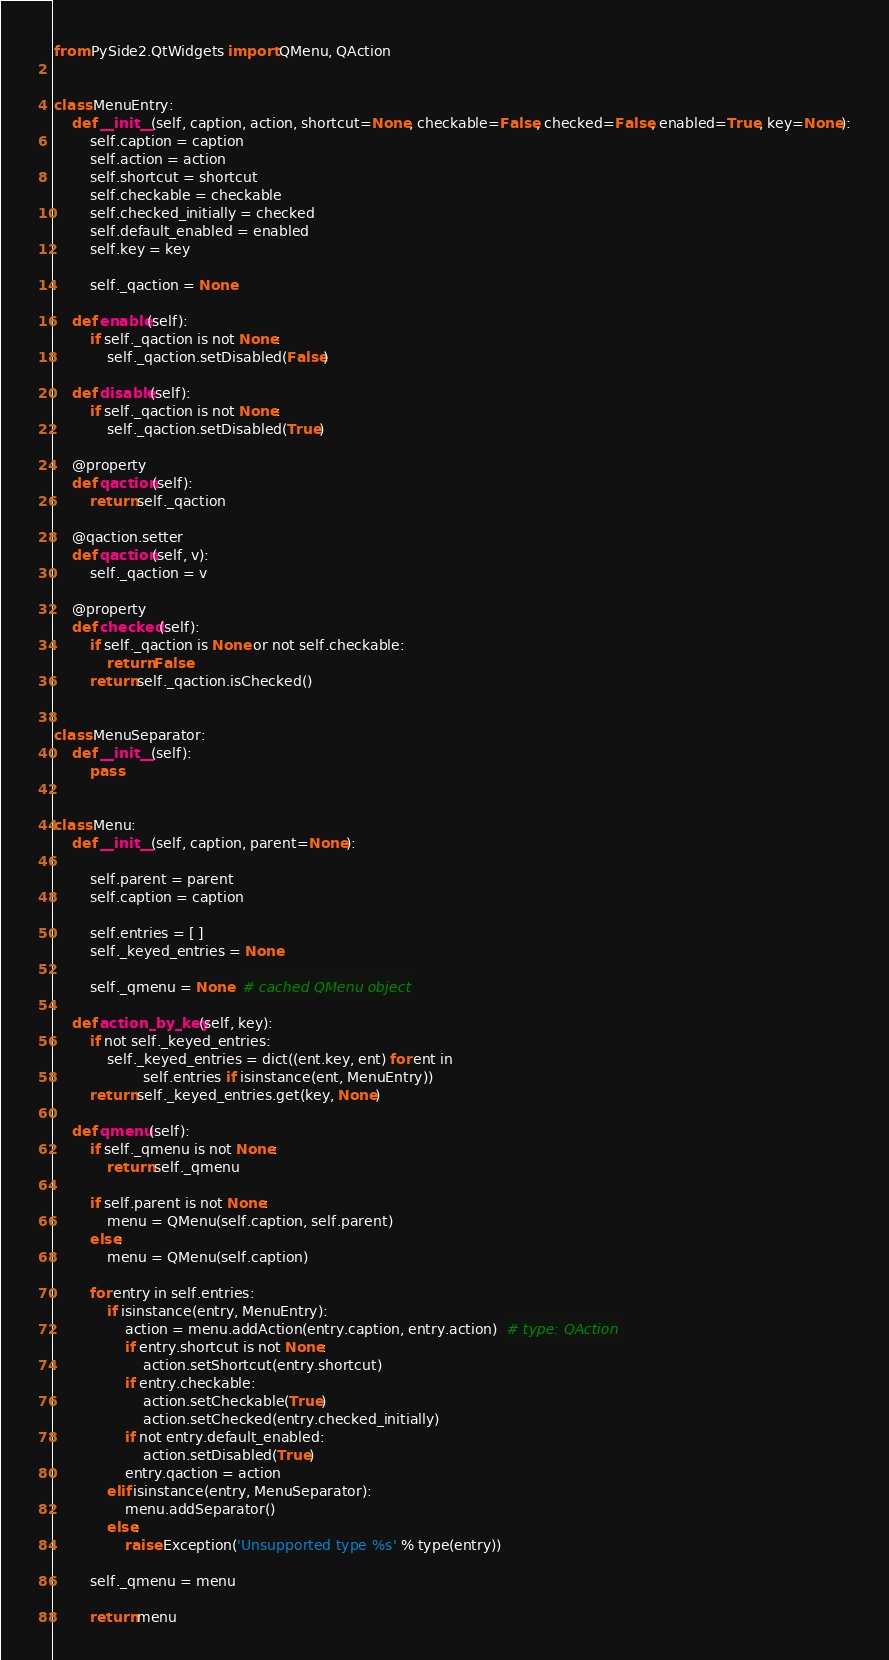<code> <loc_0><loc_0><loc_500><loc_500><_Python_>from PySide2.QtWidgets import QMenu, QAction


class MenuEntry:
    def __init__(self, caption, action, shortcut=None, checkable=False, checked=False, enabled=True, key=None):
        self.caption = caption
        self.action = action
        self.shortcut = shortcut
        self.checkable = checkable
        self.checked_initially = checked
        self.default_enabled = enabled
        self.key = key

        self._qaction = None

    def enable(self):
        if self._qaction is not None:
            self._qaction.setDisabled(False)

    def disable(self):
        if self._qaction is not None:
            self._qaction.setDisabled(True)

    @property
    def qaction(self):
        return self._qaction

    @qaction.setter
    def qaction(self, v):
        self._qaction = v

    @property
    def checked(self):
        if self._qaction is None or not self.checkable:
            return False
        return self._qaction.isChecked()


class MenuSeparator:
    def __init__(self):
        pass


class Menu:
    def __init__(self, caption, parent=None):

        self.parent = parent
        self.caption = caption

        self.entries = [ ]
        self._keyed_entries = None

        self._qmenu = None  # cached QMenu object

    def action_by_key(self, key):
        if not self._keyed_entries:
            self._keyed_entries = dict((ent.key, ent) for ent in
                    self.entries if isinstance(ent, MenuEntry))
        return self._keyed_entries.get(key, None)

    def qmenu(self):
        if self._qmenu is not None:
            return self._qmenu

        if self.parent is not None:
            menu = QMenu(self.caption, self.parent)
        else:
            menu = QMenu(self.caption)

        for entry in self.entries:
            if isinstance(entry, MenuEntry):
                action = menu.addAction(entry.caption, entry.action)  # type: QAction
                if entry.shortcut is not None:
                    action.setShortcut(entry.shortcut)
                if entry.checkable:
                    action.setCheckable(True)
                    action.setChecked(entry.checked_initially)
                if not entry.default_enabled:
                    action.setDisabled(True)
                entry.qaction = action
            elif isinstance(entry, MenuSeparator):
                menu.addSeparator()
            else:
                raise Exception('Unsupported type %s' % type(entry))

        self._qmenu = menu

        return menu
</code> 